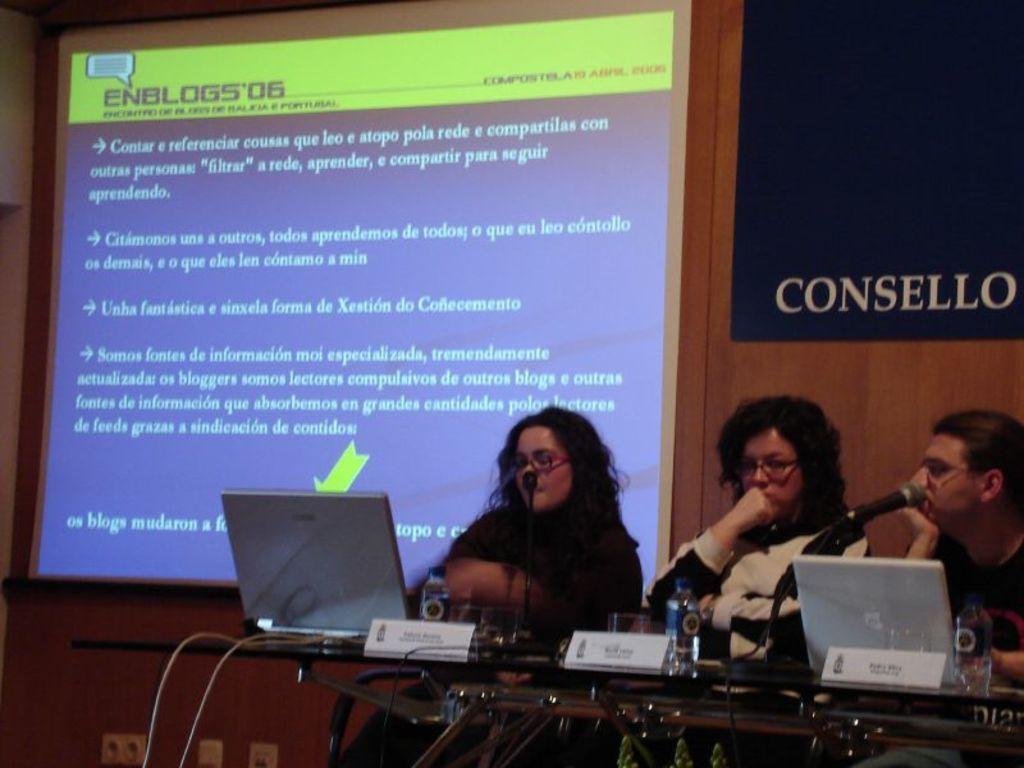How would you summarize this image in a sentence or two? At the top of the image we can see display screen and an advertisement on the wall. At the bottom of the image we can see persons sitting on the chairs and a table is placed in front of them. On the table there are cables, laptops, name plates, glass tumblers, mics and disposal bottles. 